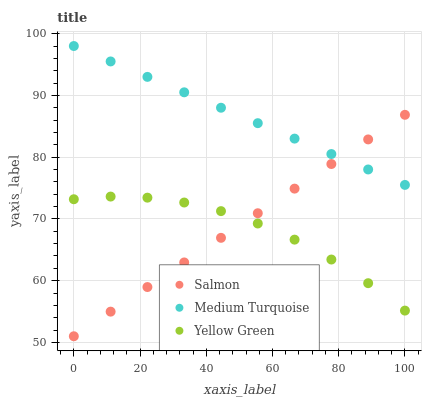Does Yellow Green have the minimum area under the curve?
Answer yes or no. Yes. Does Medium Turquoise have the maximum area under the curve?
Answer yes or no. Yes. Does Medium Turquoise have the minimum area under the curve?
Answer yes or no. No. Does Yellow Green have the maximum area under the curve?
Answer yes or no. No. Is Medium Turquoise the smoothest?
Answer yes or no. Yes. Is Yellow Green the roughest?
Answer yes or no. Yes. Is Yellow Green the smoothest?
Answer yes or no. No. Is Medium Turquoise the roughest?
Answer yes or no. No. Does Salmon have the lowest value?
Answer yes or no. Yes. Does Yellow Green have the lowest value?
Answer yes or no. No. Does Medium Turquoise have the highest value?
Answer yes or no. Yes. Does Yellow Green have the highest value?
Answer yes or no. No. Is Yellow Green less than Medium Turquoise?
Answer yes or no. Yes. Is Medium Turquoise greater than Yellow Green?
Answer yes or no. Yes. Does Salmon intersect Yellow Green?
Answer yes or no. Yes. Is Salmon less than Yellow Green?
Answer yes or no. No. Is Salmon greater than Yellow Green?
Answer yes or no. No. Does Yellow Green intersect Medium Turquoise?
Answer yes or no. No. 